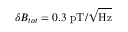Convert formula to latex. <formula><loc_0><loc_0><loc_500><loc_500>\delta B _ { t o t } = 0 . 3 p T / \sqrt { H z }</formula> 